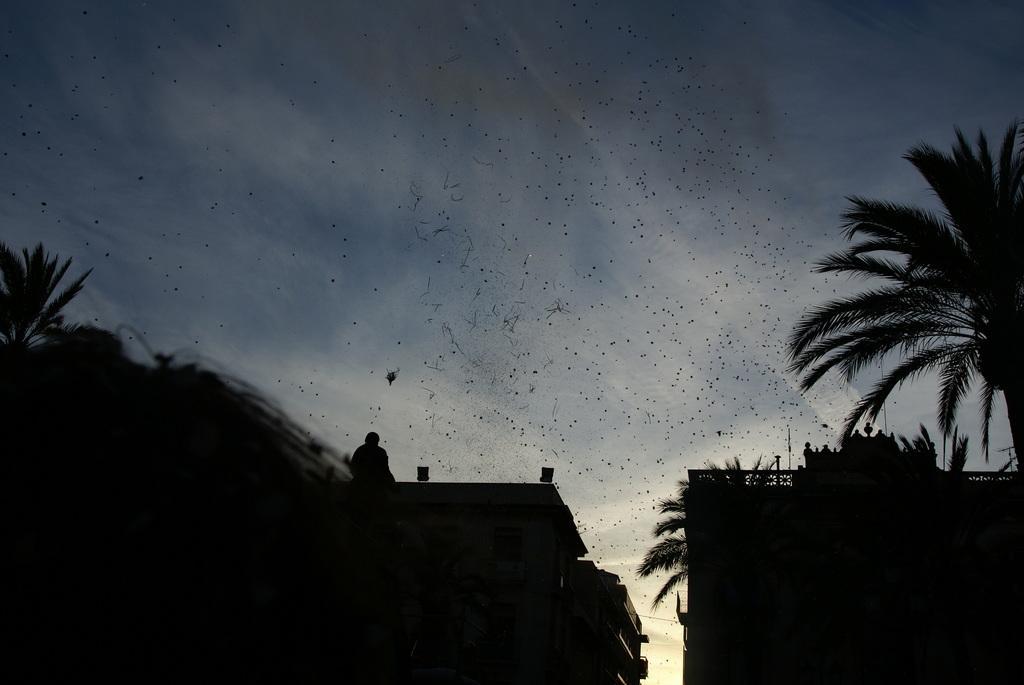Can you describe this image briefly? In the foreground of this image, on the bottom, there is a black shade of trees and the buildings on which a person is standing. On the top, there are dust particles and the smoke in the air. In the background, there is the sky and the cloud. 